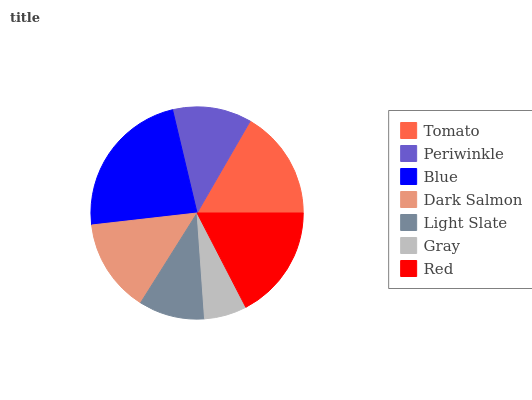Is Gray the minimum?
Answer yes or no. Yes. Is Blue the maximum?
Answer yes or no. Yes. Is Periwinkle the minimum?
Answer yes or no. No. Is Periwinkle the maximum?
Answer yes or no. No. Is Tomato greater than Periwinkle?
Answer yes or no. Yes. Is Periwinkle less than Tomato?
Answer yes or no. Yes. Is Periwinkle greater than Tomato?
Answer yes or no. No. Is Tomato less than Periwinkle?
Answer yes or no. No. Is Dark Salmon the high median?
Answer yes or no. Yes. Is Dark Salmon the low median?
Answer yes or no. Yes. Is Gray the high median?
Answer yes or no. No. Is Tomato the low median?
Answer yes or no. No. 